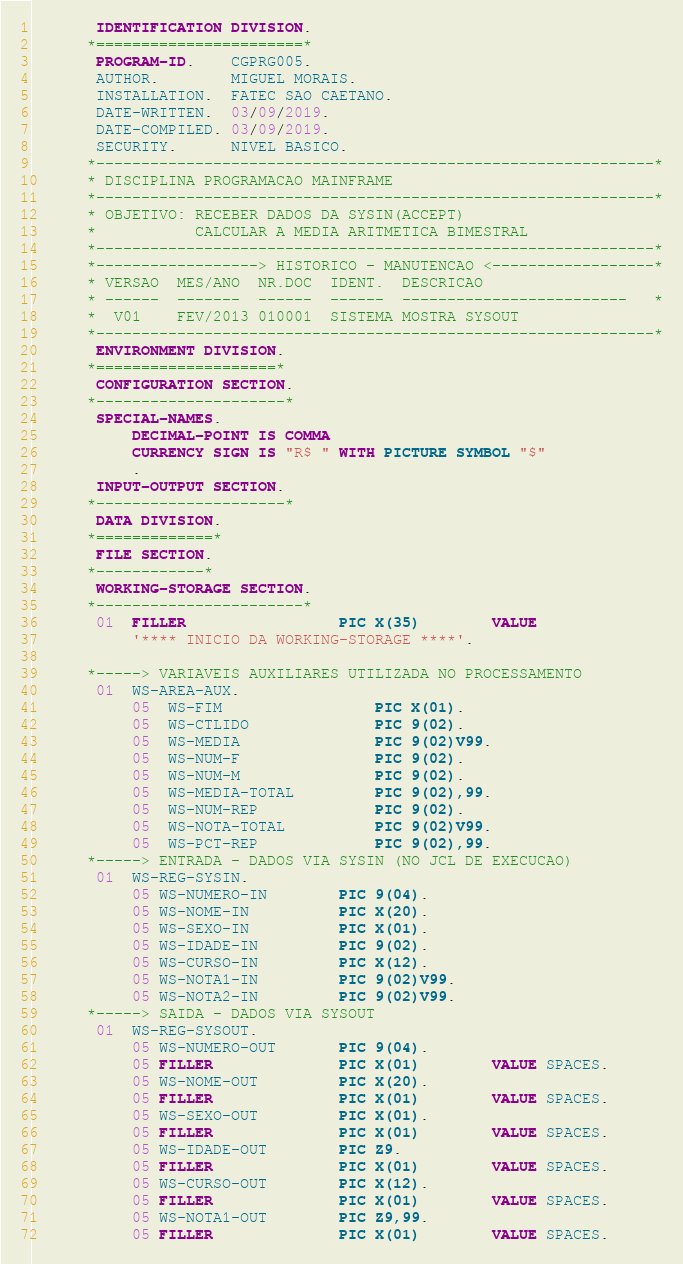Convert code to text. <code><loc_0><loc_0><loc_500><loc_500><_COBOL_>       IDENTIFICATION DIVISION.
      *=======================*
       PROGRAM-ID.    CGPRG005.
       AUTHOR.        MIGUEL MORAIS.
       INSTALLATION.  FATEC SAO CAETANO.
       DATE-WRITTEN.  03/09/2019.
       DATE-COMPILED. 03/09/2019.
       SECURITY.      NIVEL BASICO.
      *--------------------------------------------------------------*
      * DISCIPLINA PROGRAMACAO MAINFRAME
      *--------------------------------------------------------------*
      * OBJETIVO: RECEBER DADOS DA SYSIN(ACCEPT)
      *           CALCULAR A MEDIA ARITMETICA BIMESTRAL
      *--------------------------------------------------------------*
      *------------------> HISTORICO - MANUTENCAO <------------------*
      * VERSAO  MES/ANO  NR.DOC  IDENT.  DESCRICAO
      * ------  -------  ------  ------  -------------------------   *
      *  V01    FEV/2013 010001  SISTEMA MOSTRA SYSOUT
      *--------------------------------------------------------------*
       ENVIRONMENT DIVISION.
      *====================*
       CONFIGURATION SECTION.
      *---------------------*
       SPECIAL-NAMES.
           DECIMAL-POINT IS COMMA
           CURRENCY SIGN IS "R$ " WITH PICTURE SYMBOL "$"
           .
       INPUT-OUTPUT SECTION.
      *---------------------*
       DATA DIVISION.
      *=============*
       FILE SECTION.
      *------------*
       WORKING-STORAGE SECTION.
      *-----------------------*
       01  FILLER                 PIC X(35)        VALUE
           '**** INICIO DA WORKING-STORAGE ****'.

      *-----> VARIAVEIS AUXILIARES UTILIZADA NO PROCESSAMENTO
       01  WS-AREA-AUX.
           05  WS-FIM                 PIC X(01).
           05  WS-CTLIDO              PIC 9(02).
           05  WS-MEDIA               PIC 9(02)V99.
           05  WS-NUM-F               PIC 9(02).
           05  WS-NUM-M               PIC 9(02).
           05  WS-MEDIA-TOTAL         PIC 9(02),99.
           05  WS-NUM-REP             PIC 9(02).
           05  WS-NOTA-TOTAL          PIC 9(02)V99.
           05  WS-PCT-REP             PIC 9(02),99.
      *-----> ENTRADA - DADOS VIA SYSIN (NO JCL DE EXECUCAO)
       01  WS-REG-SYSIN.
           05 WS-NUMERO-IN        PIC 9(04).
           05 WS-NOME-IN          PIC X(20).
           05 WS-SEXO-IN          PIC X(01).
           05 WS-IDADE-IN         PIC 9(02).
           05 WS-CURSO-IN         PIC X(12).
           05 WS-NOTA1-IN         PIC 9(02)V99.
           05 WS-NOTA2-IN         PIC 9(02)V99.
      *-----> SAIDA - DADOS VIA SYSOUT
       01  WS-REG-SYSOUT.
           05 WS-NUMERO-OUT       PIC 9(04).
           05 FILLER              PIC X(01)        VALUE SPACES.
           05 WS-NOME-OUT         PIC X(20).
           05 FILLER              PIC X(01)        VALUE SPACES.
           05 WS-SEXO-OUT         PIC X(01).
           05 FILLER              PIC X(01)        VALUE SPACES.
           05 WS-IDADE-OUT        PIC Z9.
           05 FILLER              PIC X(01)        VALUE SPACES.
           05 WS-CURSO-OUT        PIC X(12).
           05 FILLER              PIC X(01)        VALUE SPACES.
           05 WS-NOTA1-OUT        PIC Z9,99.
           05 FILLER              PIC X(01)        VALUE SPACES.</code> 